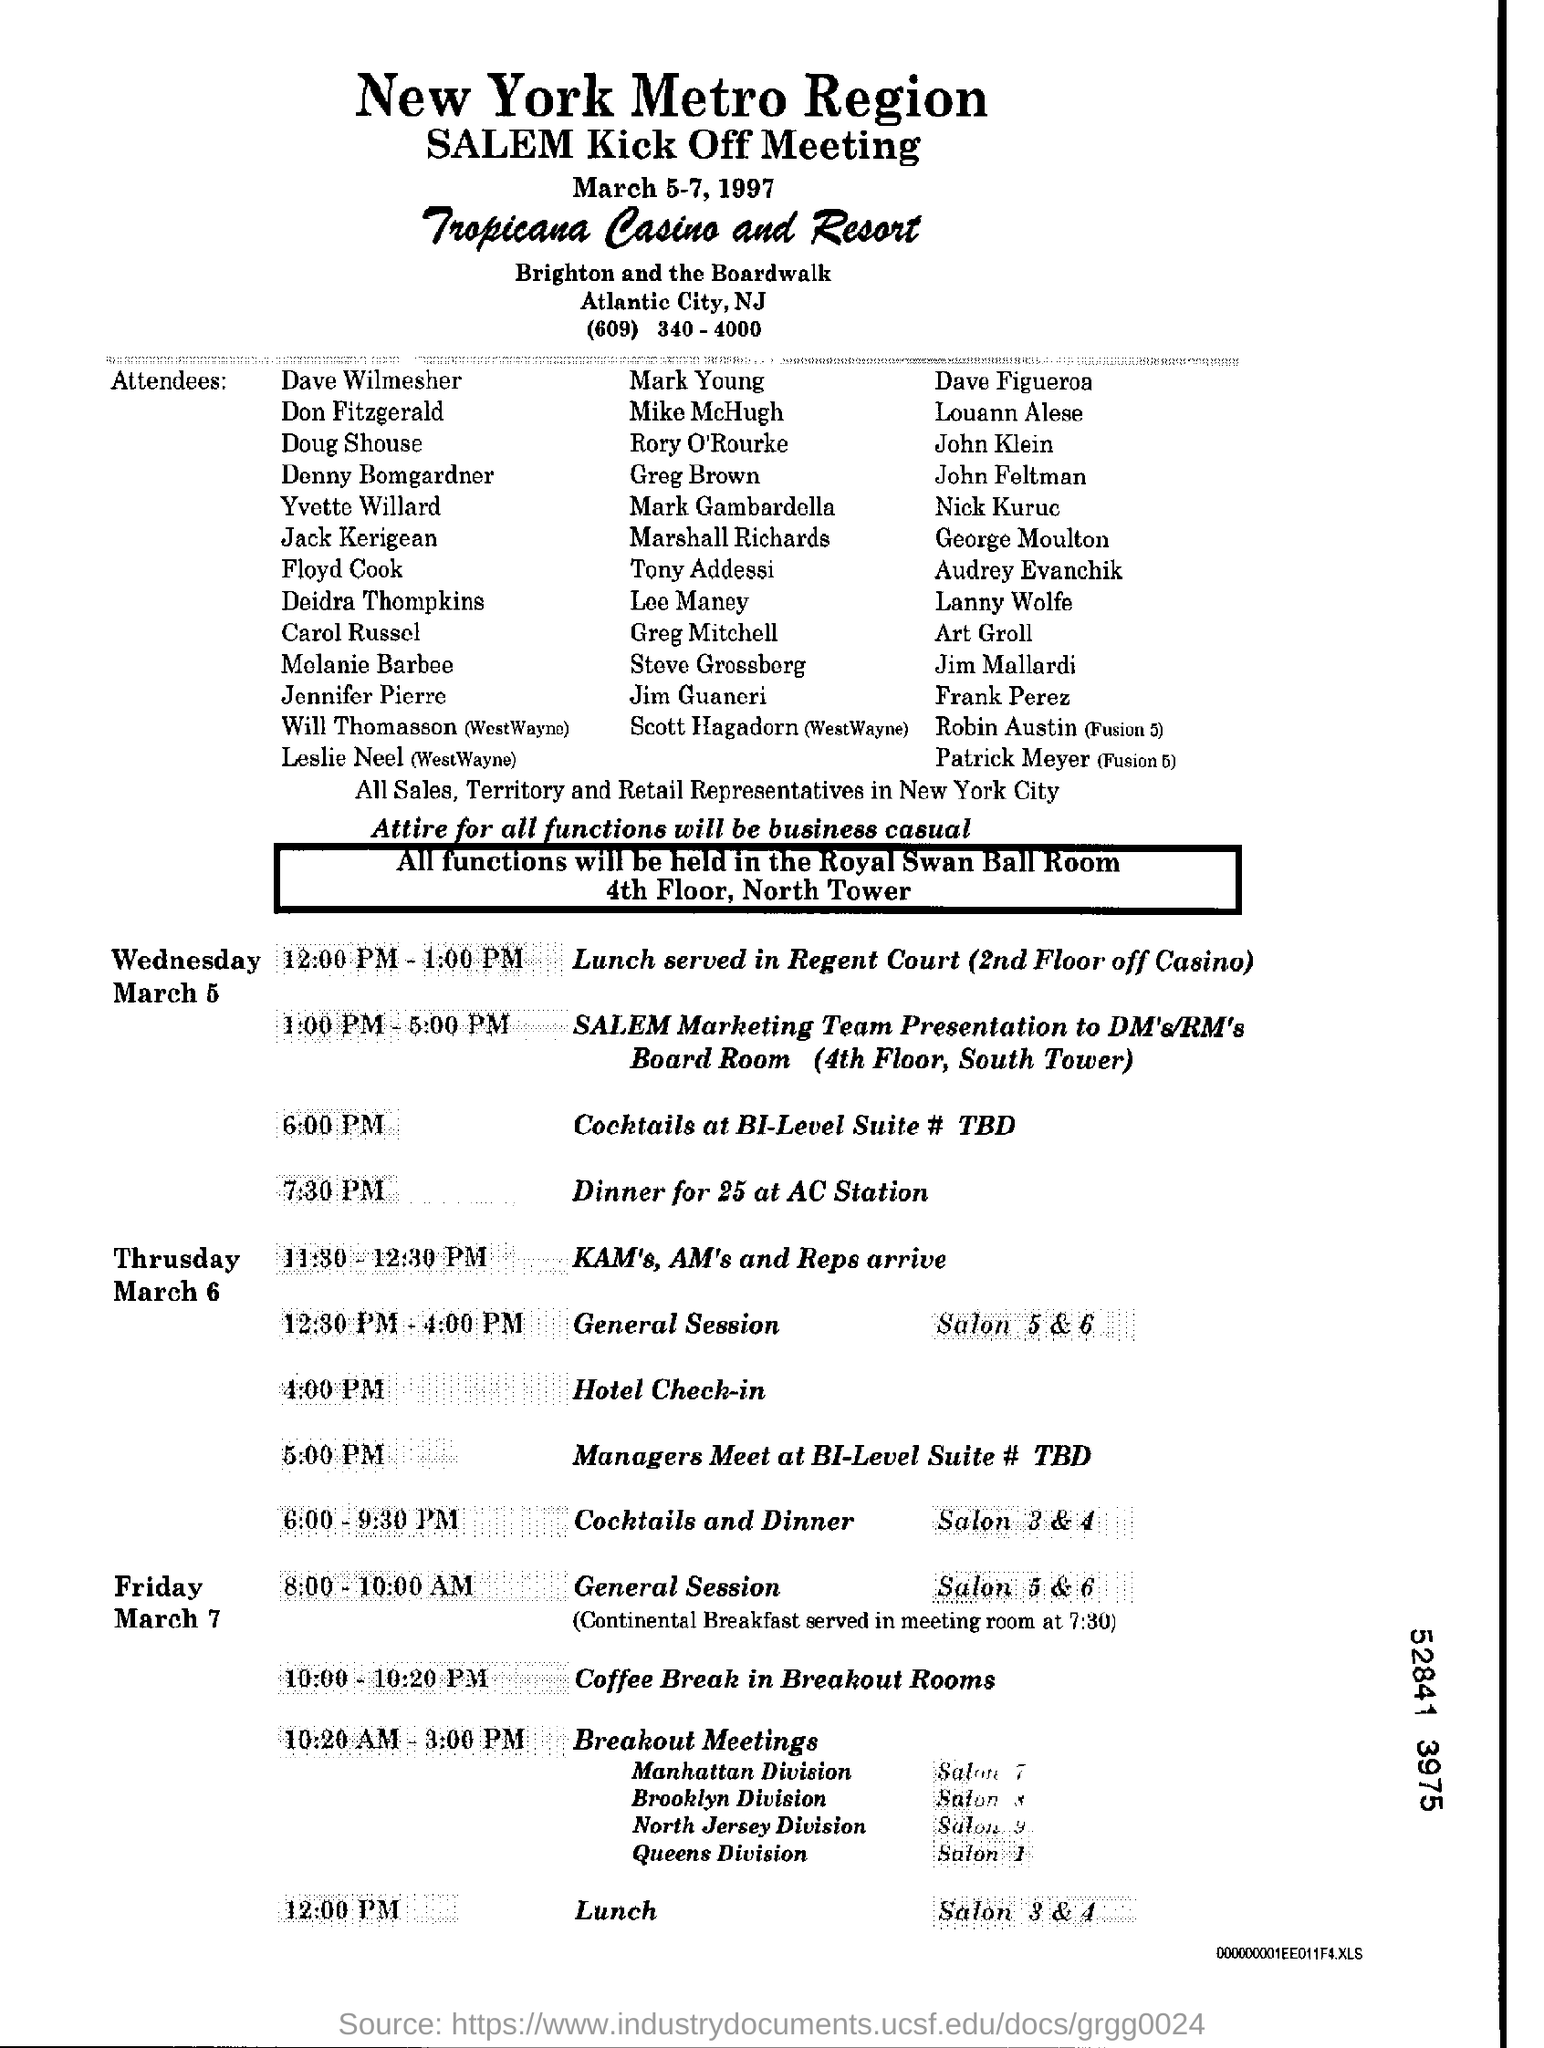Can you tell what type of events are scheduled before and after lunch on Friday? Before lunch on Friday, there is a 'General Session' scheduled from 8:00 AM to 10:00 AM, which includes a Continental Breakfast at 7:30 AM. After lunch, 'Breakout Meetings' are planned to run from 10:20 AM to 3:00 PM across multiple divisions. 